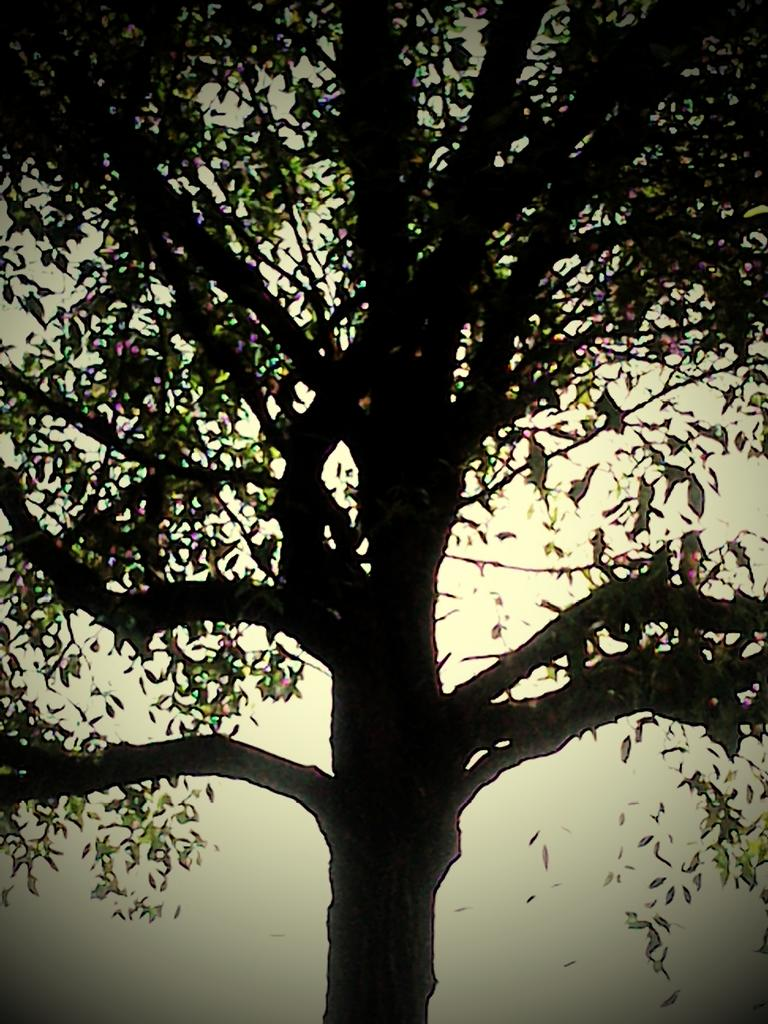What type of plant is in the middle of the image? There is a tree with leaves in the image. Where is the tree located in relation to the image? The tree is in the middle of the image. What can be seen in the background of the image? The sky is visible in the background of the image. Can you see a ghost sitting on a branch of the tree in the image? There is no ghost present in the image; it only features a tree with leaves. What type of iron object is hanging from the tree in the image? There is no iron object hanging from the tree in the image; it only features a tree with leaves. 